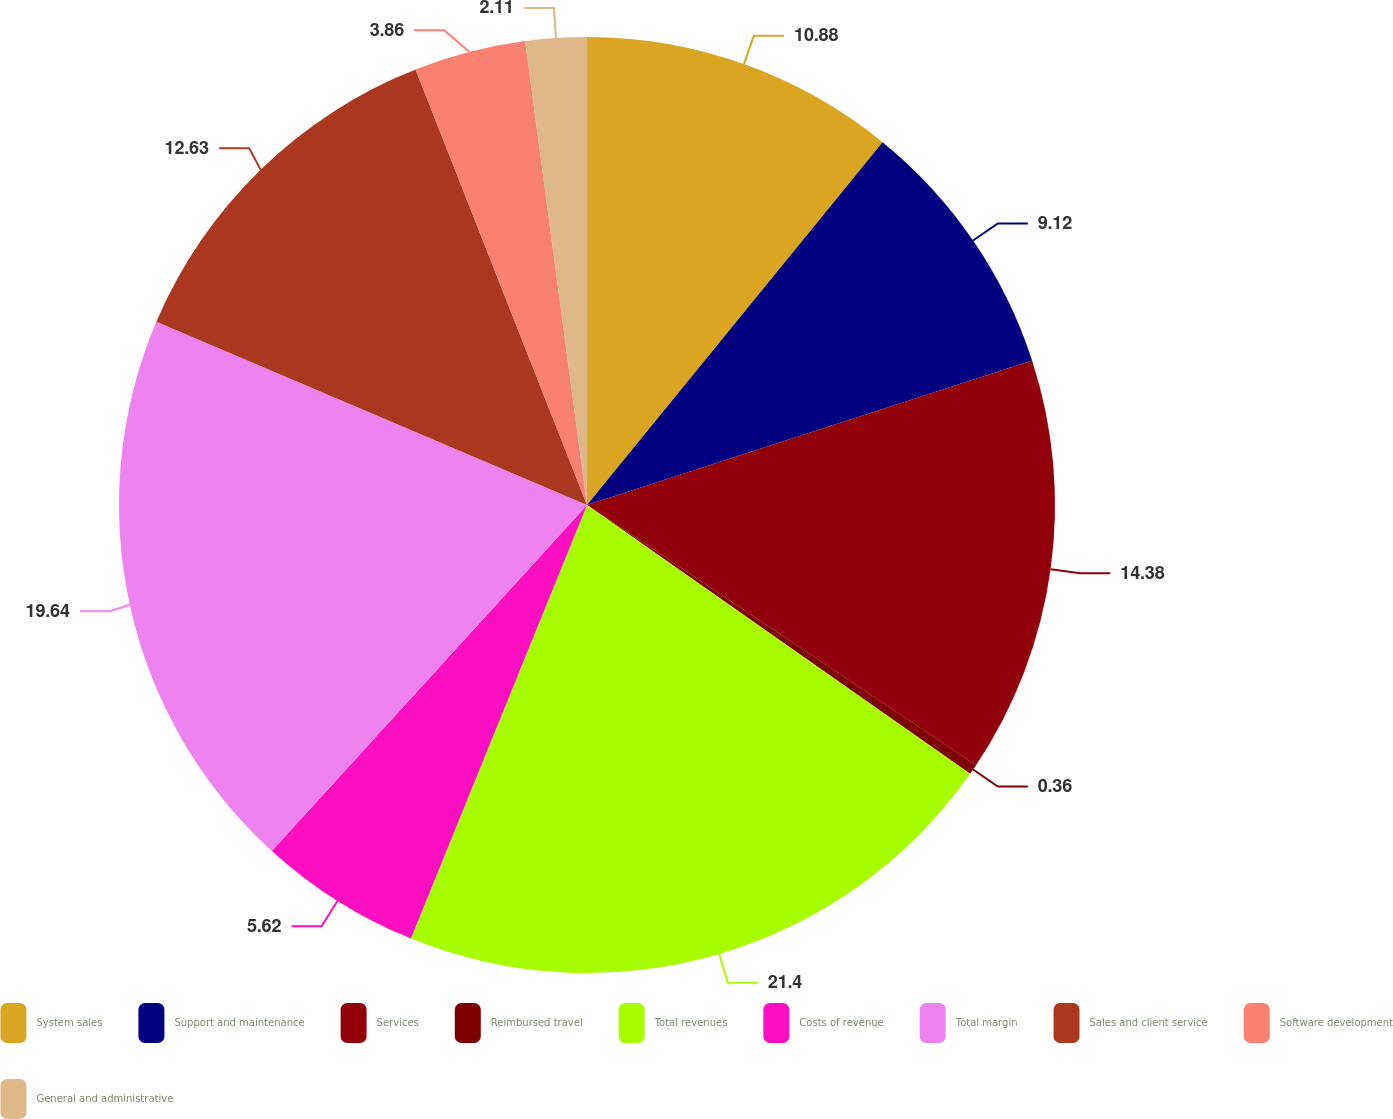Convert chart. <chart><loc_0><loc_0><loc_500><loc_500><pie_chart><fcel>System sales<fcel>Support and maintenance<fcel>Services<fcel>Reimbursed travel<fcel>Total revenues<fcel>Costs of revenue<fcel>Total margin<fcel>Sales and client service<fcel>Software development<fcel>General and administrative<nl><fcel>10.88%<fcel>9.12%<fcel>14.38%<fcel>0.36%<fcel>21.4%<fcel>5.62%<fcel>19.64%<fcel>12.63%<fcel>3.86%<fcel>2.11%<nl></chart> 